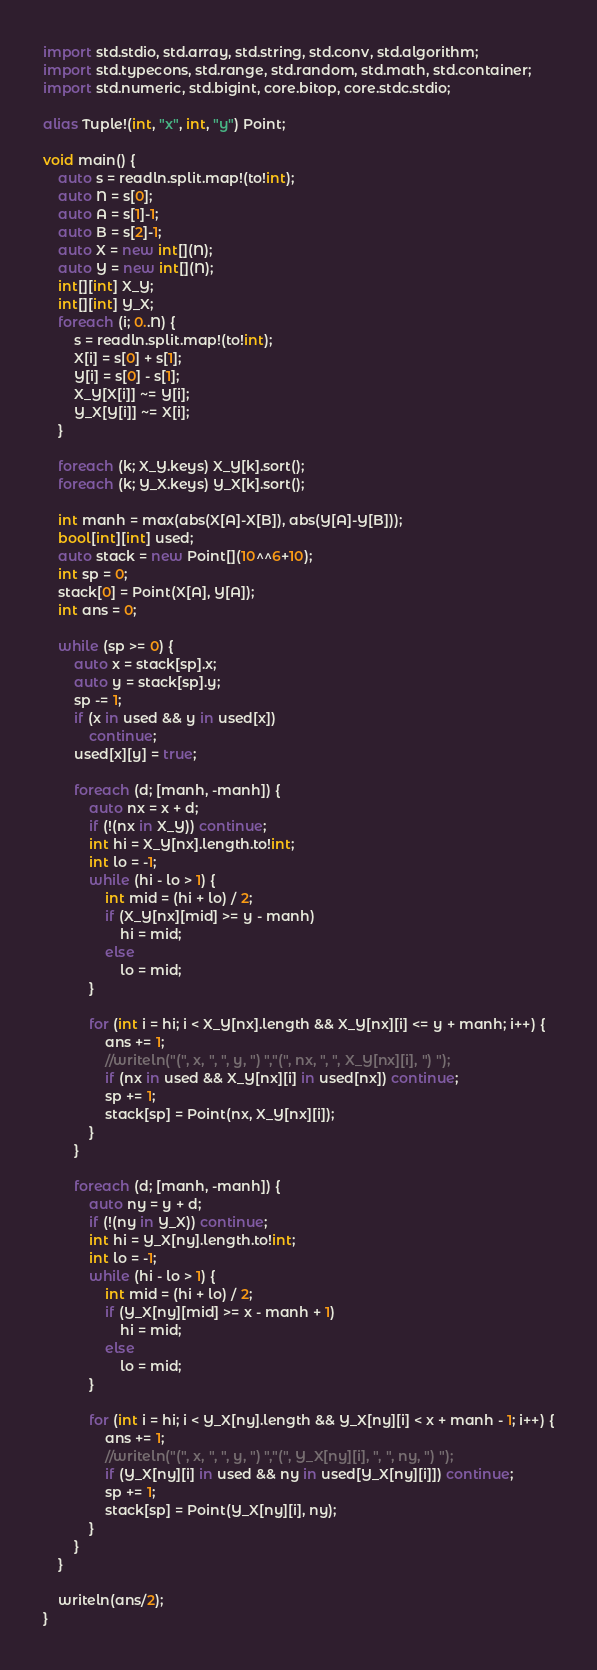<code> <loc_0><loc_0><loc_500><loc_500><_D_>import std.stdio, std.array, std.string, std.conv, std.algorithm;
import std.typecons, std.range, std.random, std.math, std.container;
import std.numeric, std.bigint, core.bitop, core.stdc.stdio;
     
alias Tuple!(int, "x", int, "y") Point;
     
void main() {
    auto s = readln.split.map!(to!int);
    auto N = s[0];
    auto A = s[1]-1;
    auto B = s[2]-1;
    auto X = new int[](N);
    auto Y = new int[](N);
    int[][int] X_Y;
    int[][int] Y_X;
    foreach (i; 0..N) {
        s = readln.split.map!(to!int);
        X[i] = s[0] + s[1];
        Y[i] = s[0] - s[1];
        X_Y[X[i]] ~= Y[i];
        Y_X[Y[i]] ~= X[i];
    }
     
    foreach (k; X_Y.keys) X_Y[k].sort();
    foreach (k; Y_X.keys) Y_X[k].sort();
     
    int manh = max(abs(X[A]-X[B]), abs(Y[A]-Y[B]));
    bool[int][int] used;
    auto stack = new Point[](10^^6+10);
    int sp = 0;
    stack[0] = Point(X[A], Y[A]);
    int ans = 0;
        
    while (sp >= 0) {
        auto x = stack[sp].x;
        auto y = stack[sp].y;
        sp -= 1;
        if (x in used && y in used[x])
            continue;
        used[x][y] = true;
     
        foreach (d; [manh, -manh]) {
            auto nx = x + d;
            if (!(nx in X_Y)) continue;
            int hi = X_Y[nx].length.to!int;
            int lo = -1;
            while (hi - lo > 1) {
                int mid = (hi + lo) / 2;
                if (X_Y[nx][mid] >= y - manh)
                    hi = mid;
                else
                    lo = mid;
            }
     
            for (int i = hi; i < X_Y[nx].length && X_Y[nx][i] <= y + manh; i++) {
                ans += 1;
                //writeln("(", x, ", ", y, ") ","(", nx, ", ", X_Y[nx][i], ") ");
                if (nx in used && X_Y[nx][i] in used[nx]) continue;
                sp += 1;
                stack[sp] = Point(nx, X_Y[nx][i]);
            }
        }
     
        foreach (d; [manh, -manh]) {
            auto ny = y + d;
            if (!(ny in Y_X)) continue;
            int hi = Y_X[ny].length.to!int;
            int lo = -1;
            while (hi - lo > 1) {
                int mid = (hi + lo) / 2;
                if (Y_X[ny][mid] >= x - manh + 1)
                    hi = mid;
                else
                    lo = mid;
            }
     
            for (int i = hi; i < Y_X[ny].length && Y_X[ny][i] < x + manh - 1; i++) {
                ans += 1;
                //writeln("(", x, ", ", y, ") ","(", Y_X[ny][i], ", ", ny, ") ");
                if (Y_X[ny][i] in used && ny in used[Y_X[ny][i]]) continue;
                sp += 1;
                stack[sp] = Point(Y_X[ny][i], ny);
            }
        }        
    }
     
    writeln(ans/2);
}
</code> 